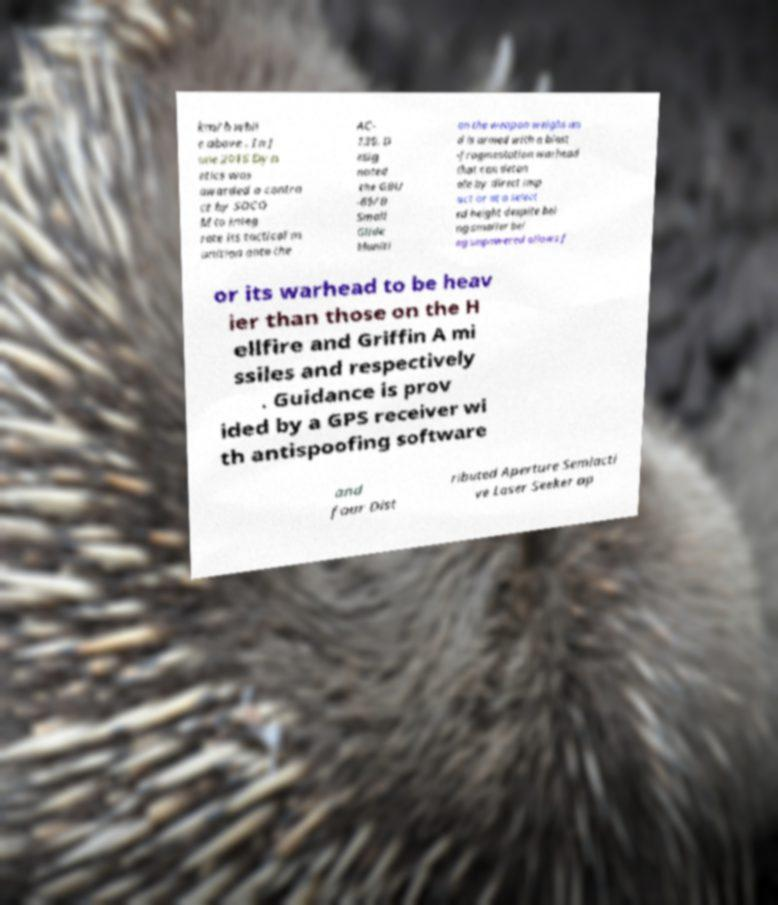I need the written content from this picture converted into text. Can you do that? km/h whil e above . In J une 2016 Dyn etics was awarded a contra ct by SOCO M to integ rate its tactical m unition onto the AC- 130. D esig nated the GBU -69/B Small Glide Muniti on the weapon weighs an d is armed with a blast -fragmentation warhead that can deton ate by direct imp act or at a select ed height despite bei ng smaller bei ng unpowered allows f or its warhead to be heav ier than those on the H ellfire and Griffin A mi ssiles and respectively . Guidance is prov ided by a GPS receiver wi th antispoofing software and four Dist ributed Aperture Semiacti ve Laser Seeker ap 